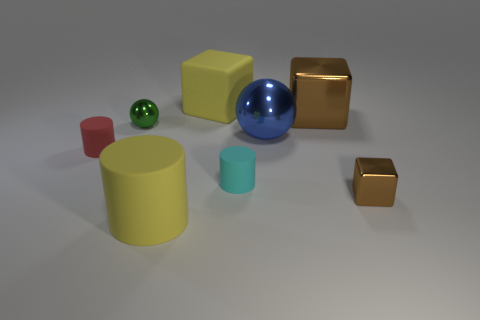What number of other things are the same color as the large rubber cube?
Keep it short and to the point. 1. There is a small matte thing that is on the right side of the small green ball; what is its color?
Your answer should be very brief. Cyan. What number of other things are made of the same material as the tiny brown block?
Your answer should be compact. 3. Are there more big objects that are behind the blue shiny object than cyan rubber cylinders that are left of the small cyan matte object?
Your answer should be compact. Yes. There is a big blue metallic ball; what number of tiny brown objects are in front of it?
Your response must be concise. 1. Are the big yellow cylinder and the big cube to the right of the big matte block made of the same material?
Keep it short and to the point. No. Is there anything else that has the same shape as the big blue thing?
Your response must be concise. Yes. Do the cyan object and the yellow block have the same material?
Offer a terse response. Yes. There is a cyan object on the left side of the blue sphere; is there a cyan rubber cylinder that is behind it?
Give a very brief answer. No. How many metallic things are both on the right side of the large yellow cylinder and to the left of the big blue object?
Provide a short and direct response. 0. 